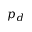Convert formula to latex. <formula><loc_0><loc_0><loc_500><loc_500>p _ { d }</formula> 